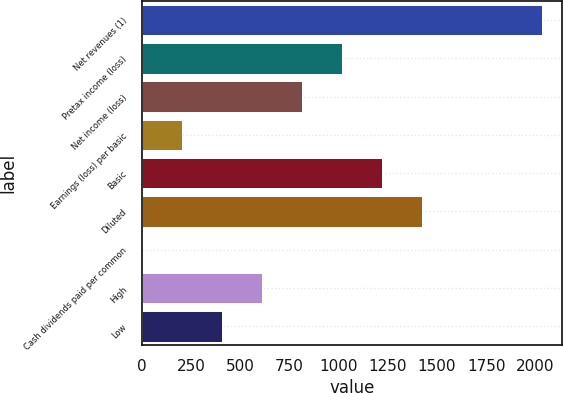Convert chart to OTSL. <chart><loc_0><loc_0><loc_500><loc_500><bar_chart><fcel>Net revenues (1)<fcel>Pretax income (loss)<fcel>Net income (loss)<fcel>Earnings (loss) per basic<fcel>Basic<fcel>Diluted<fcel>Cash dividends paid per common<fcel>High<fcel>Low<nl><fcel>2032<fcel>1016.06<fcel>812.87<fcel>203.3<fcel>1219.25<fcel>1422.44<fcel>0.11<fcel>609.68<fcel>406.49<nl></chart> 